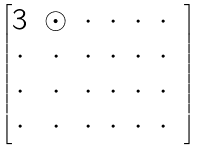Convert formula to latex. <formula><loc_0><loc_0><loc_500><loc_500>\begin{bmatrix} 3 & \odot & \cdot & \cdot & \cdot & \cdot \\ \cdot & \cdot & \cdot & \cdot & \cdot & \cdot & \\ \cdot & \cdot & \cdot & \cdot & \cdot & \cdot & \\ \cdot & \cdot & \cdot & \cdot & \cdot & \cdot & \end{bmatrix}</formula> 